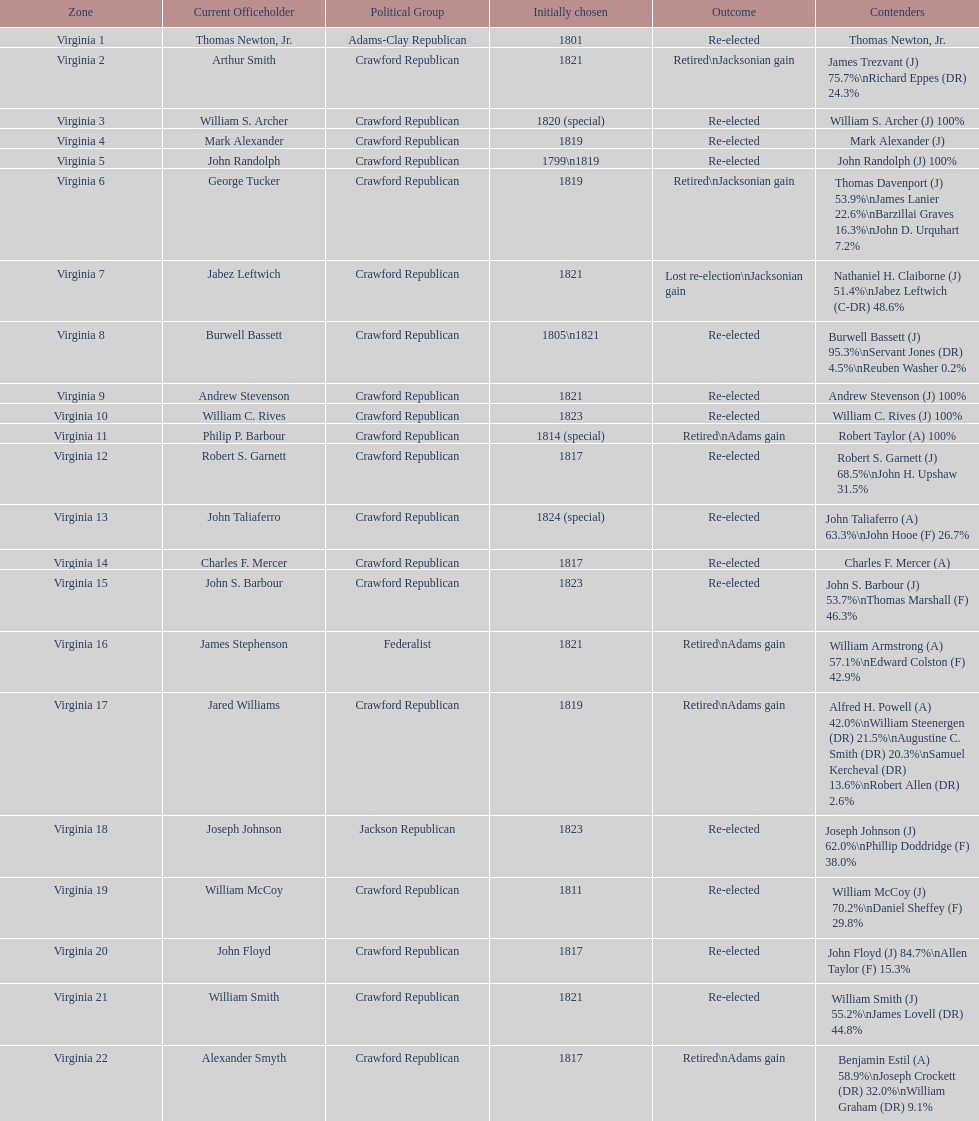What is the last party on this chart? Crawford Republican. 